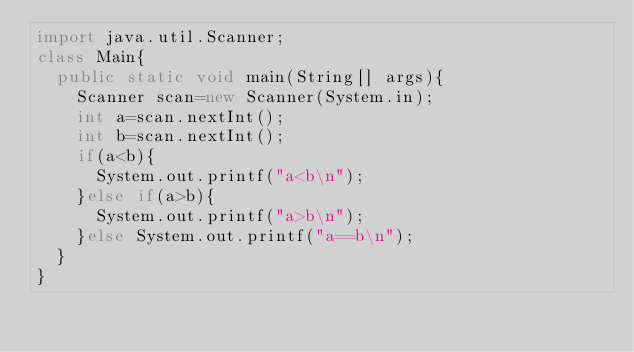Convert code to text. <code><loc_0><loc_0><loc_500><loc_500><_Java_>import java.util.Scanner;
class Main{
	public static void main(String[] args){
		Scanner scan=new Scanner(System.in);
		int a=scan.nextInt();
		int b=scan.nextInt();
		if(a<b){
			System.out.printf("a<b\n");
		}else if(a>b){
			System.out.printf("a>b\n");
		}else System.out.printf("a==b\n");
	}
}</code> 